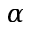<formula> <loc_0><loc_0><loc_500><loc_500>\alpha</formula> 